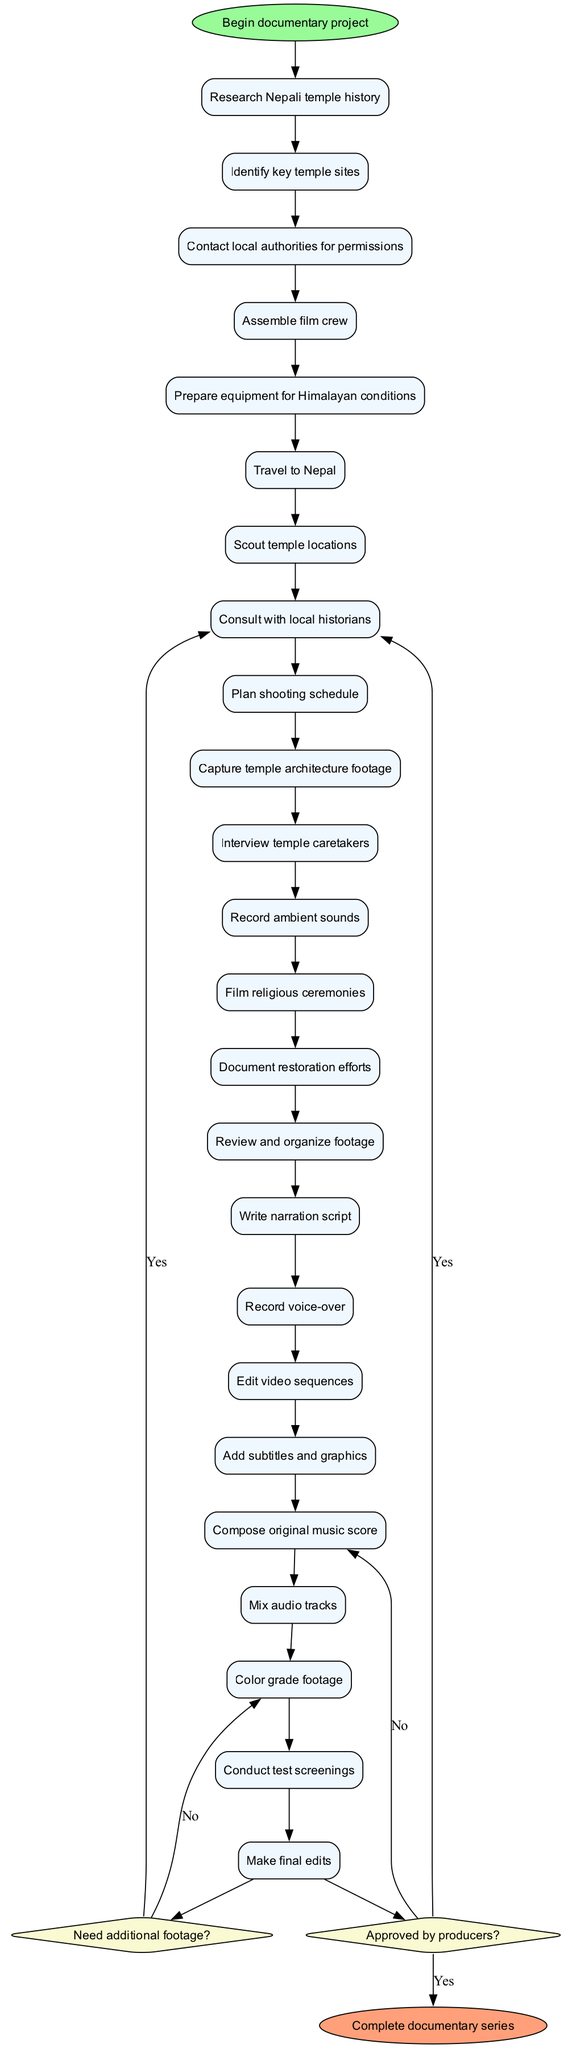What is the starting point of the documentary project? The starting point is indicated by the first node in the diagram, which states "Begin documentary project."
Answer: Begin documentary project How many activities are listed in the diagram? By counting the nodes that represent activities in the diagram, we see there are a total of 21 distinct activities outlined.
Answer: 21 What is the last activity before entering post-production? The last activity before making decisions regarding footage is "Conduct test screenings," which connects to the first decision point about needing additional footage.
Answer: Conduct test screenings What happens if the producers do not approve the documentary? If the producers do not approve the documentary, as indicated by the "no" path leading from the second decision point, the flow leads back to "Revise documentary."
Answer: Revise documentary Which activity comes directly after "Travel to Nepal"? Following "Travel to Nepal," the next activity in the sequence is "Scout temple locations," which is the subsequent step in the filming process.
Answer: Scout temple locations What is the output of the process if additional footage is needed? If additional footage is required, the diagram indicates that the flow returns to "Return to filming," allowing for more capturing of relevant scenes.
Answer: Return to filming How many decision points are present in the diagram? The diagram contains two decision points where choices are made that can alter the course of the workflow within the documentary project.
Answer: 2 What is the first activity completed in the filming process? The first activity listed in the diagram is "Research Nepali temple history," which serves as the initial step for the project before any filming begins.
Answer: Research Nepali temple history What does the diagram indicate happens after mixing audio tracks? After mixing audio tracks, the next step is "Color grade footage," as represented by the direct flow between these activities.
Answer: Color grade footage What leads to the final edits? The process flows toward "Make final edits" if the producers approve the documentary, following a successful completion of prior activities and decisions.
Answer: Make final edits 